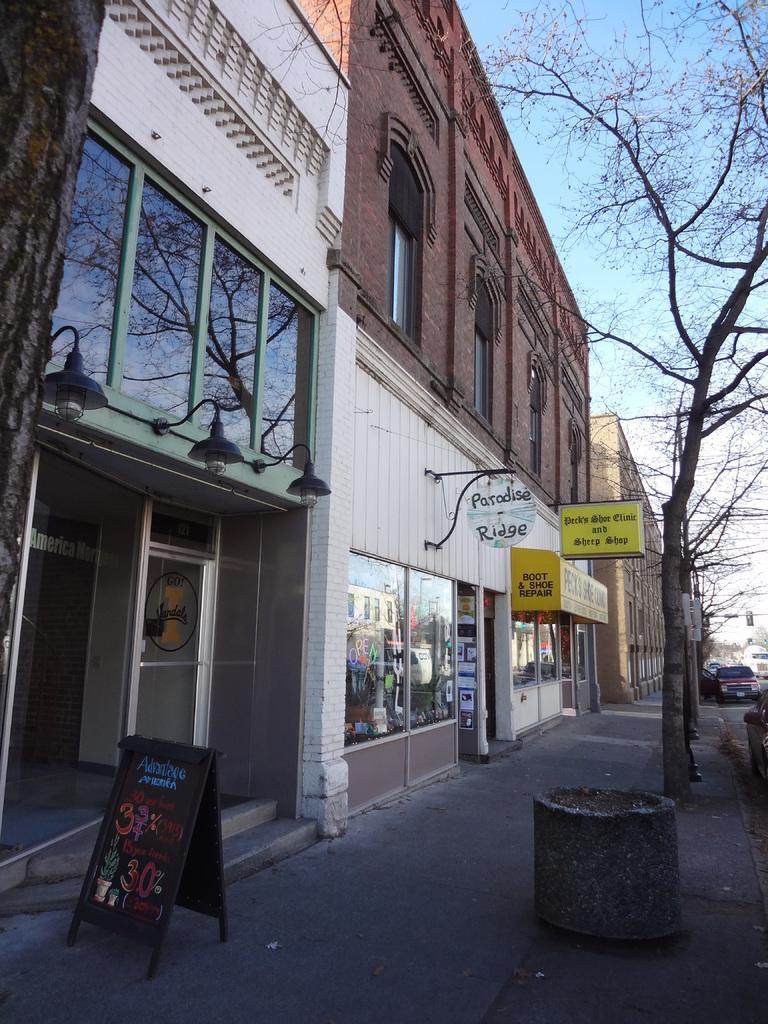Can you describe this image briefly? In the image we can see a building and the windows of the building. This is a board, light, stairs, footpath, tree and a pale blue sky. We can even see there are vehicles. 